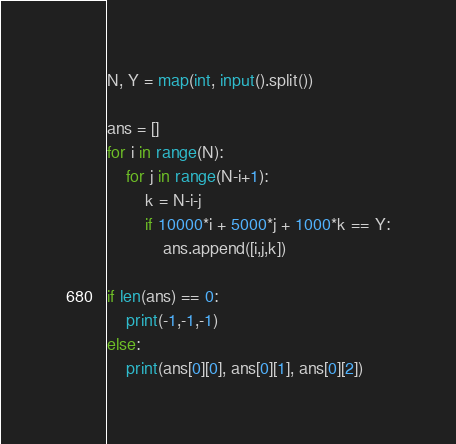<code> <loc_0><loc_0><loc_500><loc_500><_Python_>N, Y = map(int, input().split())

ans = []
for i in range(N):
    for j in range(N-i+1):
        k = N-i-j
        if 10000*i + 5000*j + 1000*k == Y:
            ans.append([i,j,k])

if len(ans) == 0:
    print(-1,-1,-1)
else:
    print(ans[0][0], ans[0][1], ans[0][2])</code> 